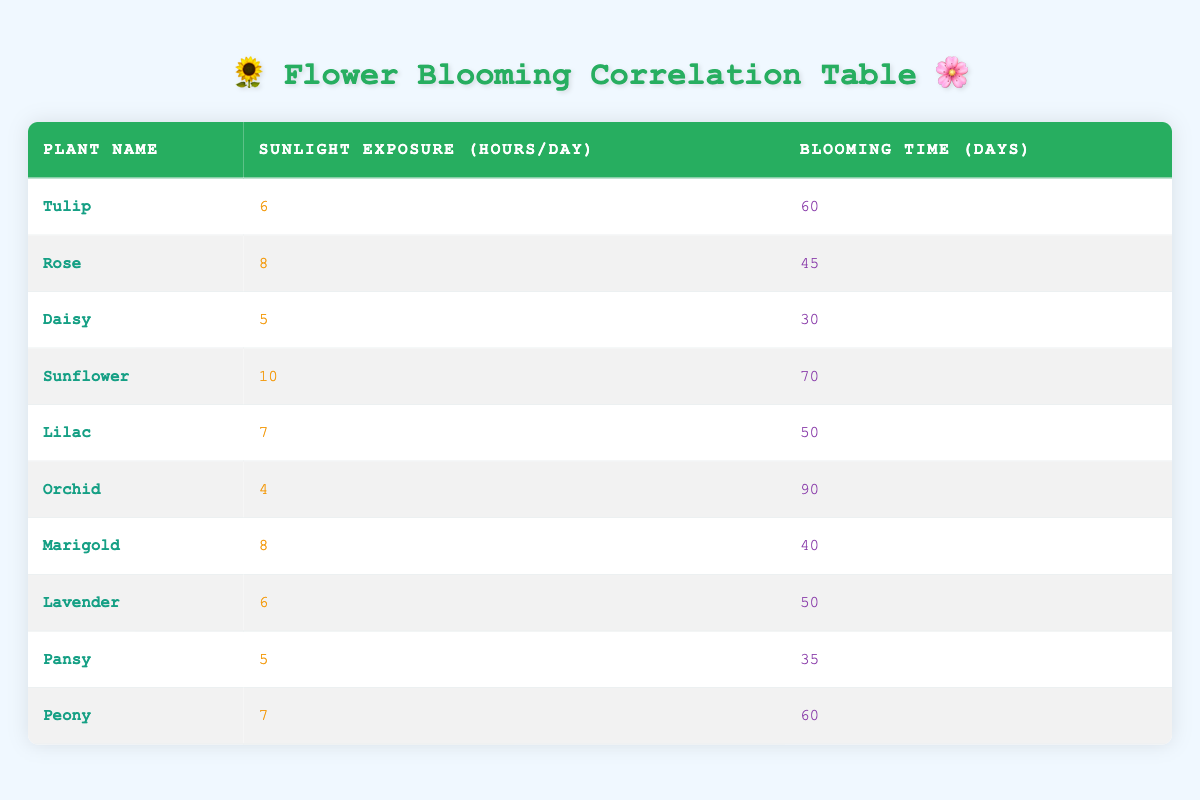What is the blooming time of the Rose? The table lists the blooming time for each plant. For the Rose, the corresponding blooming time is directly found in the same row where the Rose is listed.
Answer: 45 Which plant requires the most sunlight exposure? By examining the sunlight exposure column, we can identify the highest value. The Sunflower has the highest sunlight exposure of 10 hours per day.
Answer: Sunflower What is the average blooming time for all plants listed? To find the average, sum the blooming times: 60 + 45 + 30 + 70 + 50 + 90 + 40 + 50 + 35 + 60 = 520. There are 10 plants, so the average is 520/10 = 52 days.
Answer: 52 Is it true that the Orchid has the longest blooming time? Looking at the blooming time column, the Orchid has a blooming time of 90 days, which is indeed the longest compared to all others listed.
Answer: Yes If we consider the plants with 6 hours of sunlight, what is the total blooming time for these plants? The plants that require 6 hours of sunlight are the Tulip and Lavender. Their blooming times are 60 and 50 days respectively. Summing these gives us 60 + 50 = 110 days.
Answer: 110 Which plant has a blooming time closest to the average blooming time of the table? The average blooming time calculated previously is 52 days. Looking through the blooming times, the Lilac and Lavender both have 50 days, making them closest to the average.
Answer: Lilac and Lavender How many plants required less than 6 hours of sunlight? From the sunlight exposure column, only the Orchid needs 4 hours, and the Daisy and Pansy each require 5 hours. Thus, there are three plants with less than 6 hours of sunlight.
Answer: 3 What is the difference between the blooming time of the Sunflower and the Pansy? The blooming time for the Sunflower is 70 days while the Pansy’s blooming time is 35 days. The difference is 70 - 35 = 35 days.
Answer: 35 Which plant has the shortest blooming time? Looking through the blooming time column, the shortest blooming time is 30 days for the Daisy.
Answer: Daisy 